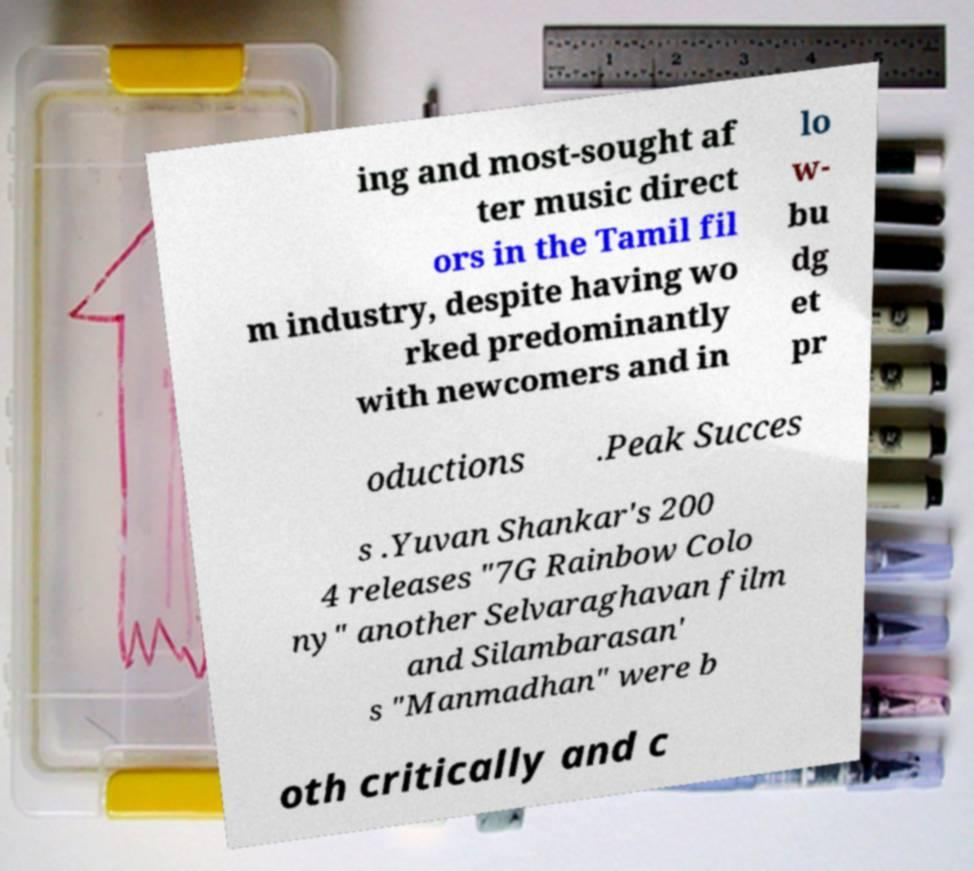What messages or text are displayed in this image? I need them in a readable, typed format. ing and most-sought af ter music direct ors in the Tamil fil m industry, despite having wo rked predominantly with newcomers and in lo w- bu dg et pr oductions .Peak Succes s .Yuvan Shankar's 200 4 releases "7G Rainbow Colo ny" another Selvaraghavan film and Silambarasan' s "Manmadhan" were b oth critically and c 